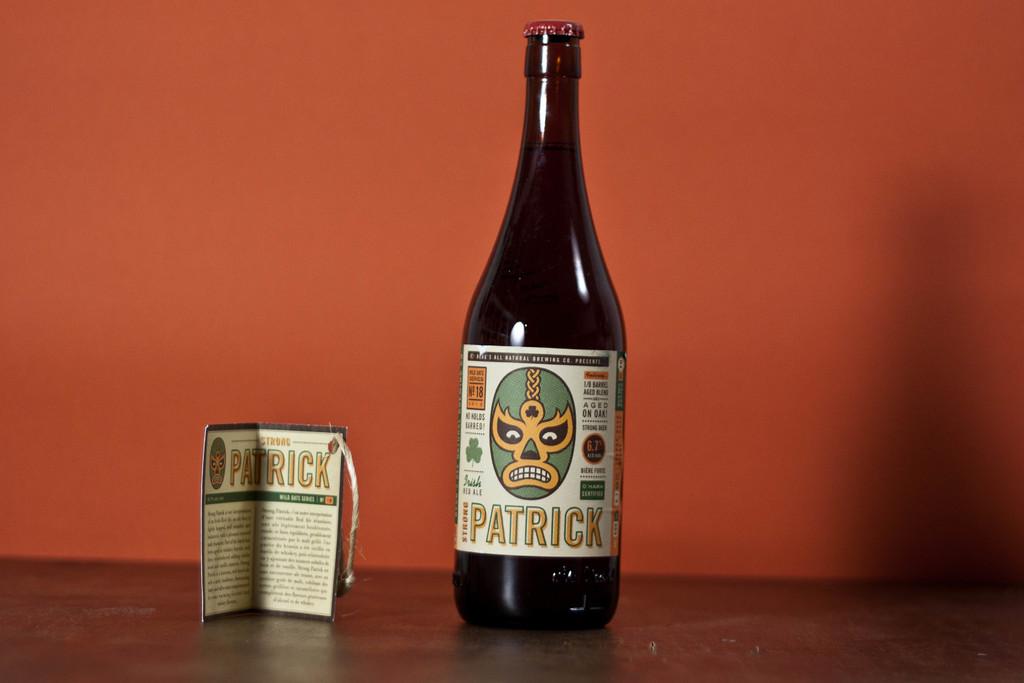What is the name of the wine?
Provide a short and direct response. Patrick. Who makes that?
Provide a short and direct response. Patrick. 